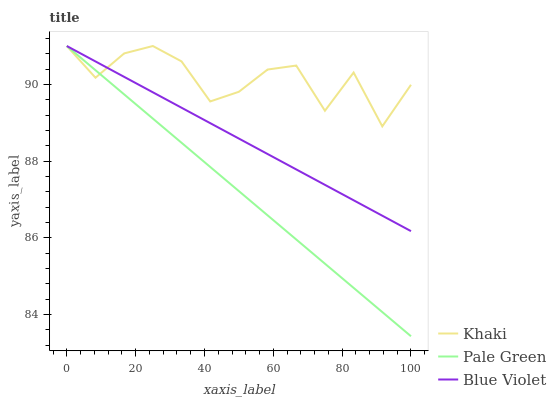Does Pale Green have the minimum area under the curve?
Answer yes or no. Yes. Does Khaki have the maximum area under the curve?
Answer yes or no. Yes. Does Blue Violet have the minimum area under the curve?
Answer yes or no. No. Does Blue Violet have the maximum area under the curve?
Answer yes or no. No. Is Blue Violet the smoothest?
Answer yes or no. Yes. Is Khaki the roughest?
Answer yes or no. Yes. Is Khaki the smoothest?
Answer yes or no. No. Is Blue Violet the roughest?
Answer yes or no. No. Does Pale Green have the lowest value?
Answer yes or no. Yes. Does Blue Violet have the lowest value?
Answer yes or no. No. Does Blue Violet have the highest value?
Answer yes or no. Yes. Does Pale Green intersect Blue Violet?
Answer yes or no. Yes. Is Pale Green less than Blue Violet?
Answer yes or no. No. Is Pale Green greater than Blue Violet?
Answer yes or no. No. 